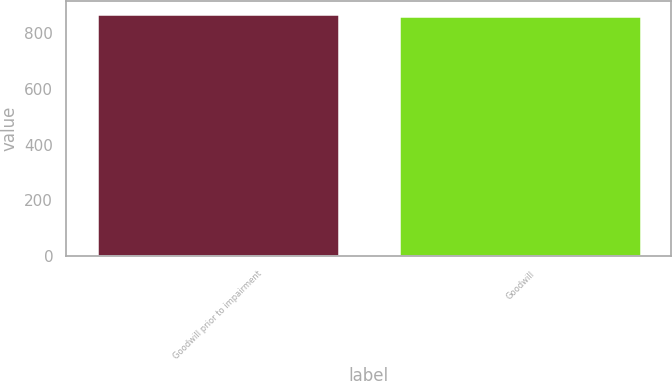<chart> <loc_0><loc_0><loc_500><loc_500><bar_chart><fcel>Goodwill prior to impairment<fcel>Goodwill<nl><fcel>871.5<fcel>862.9<nl></chart> 